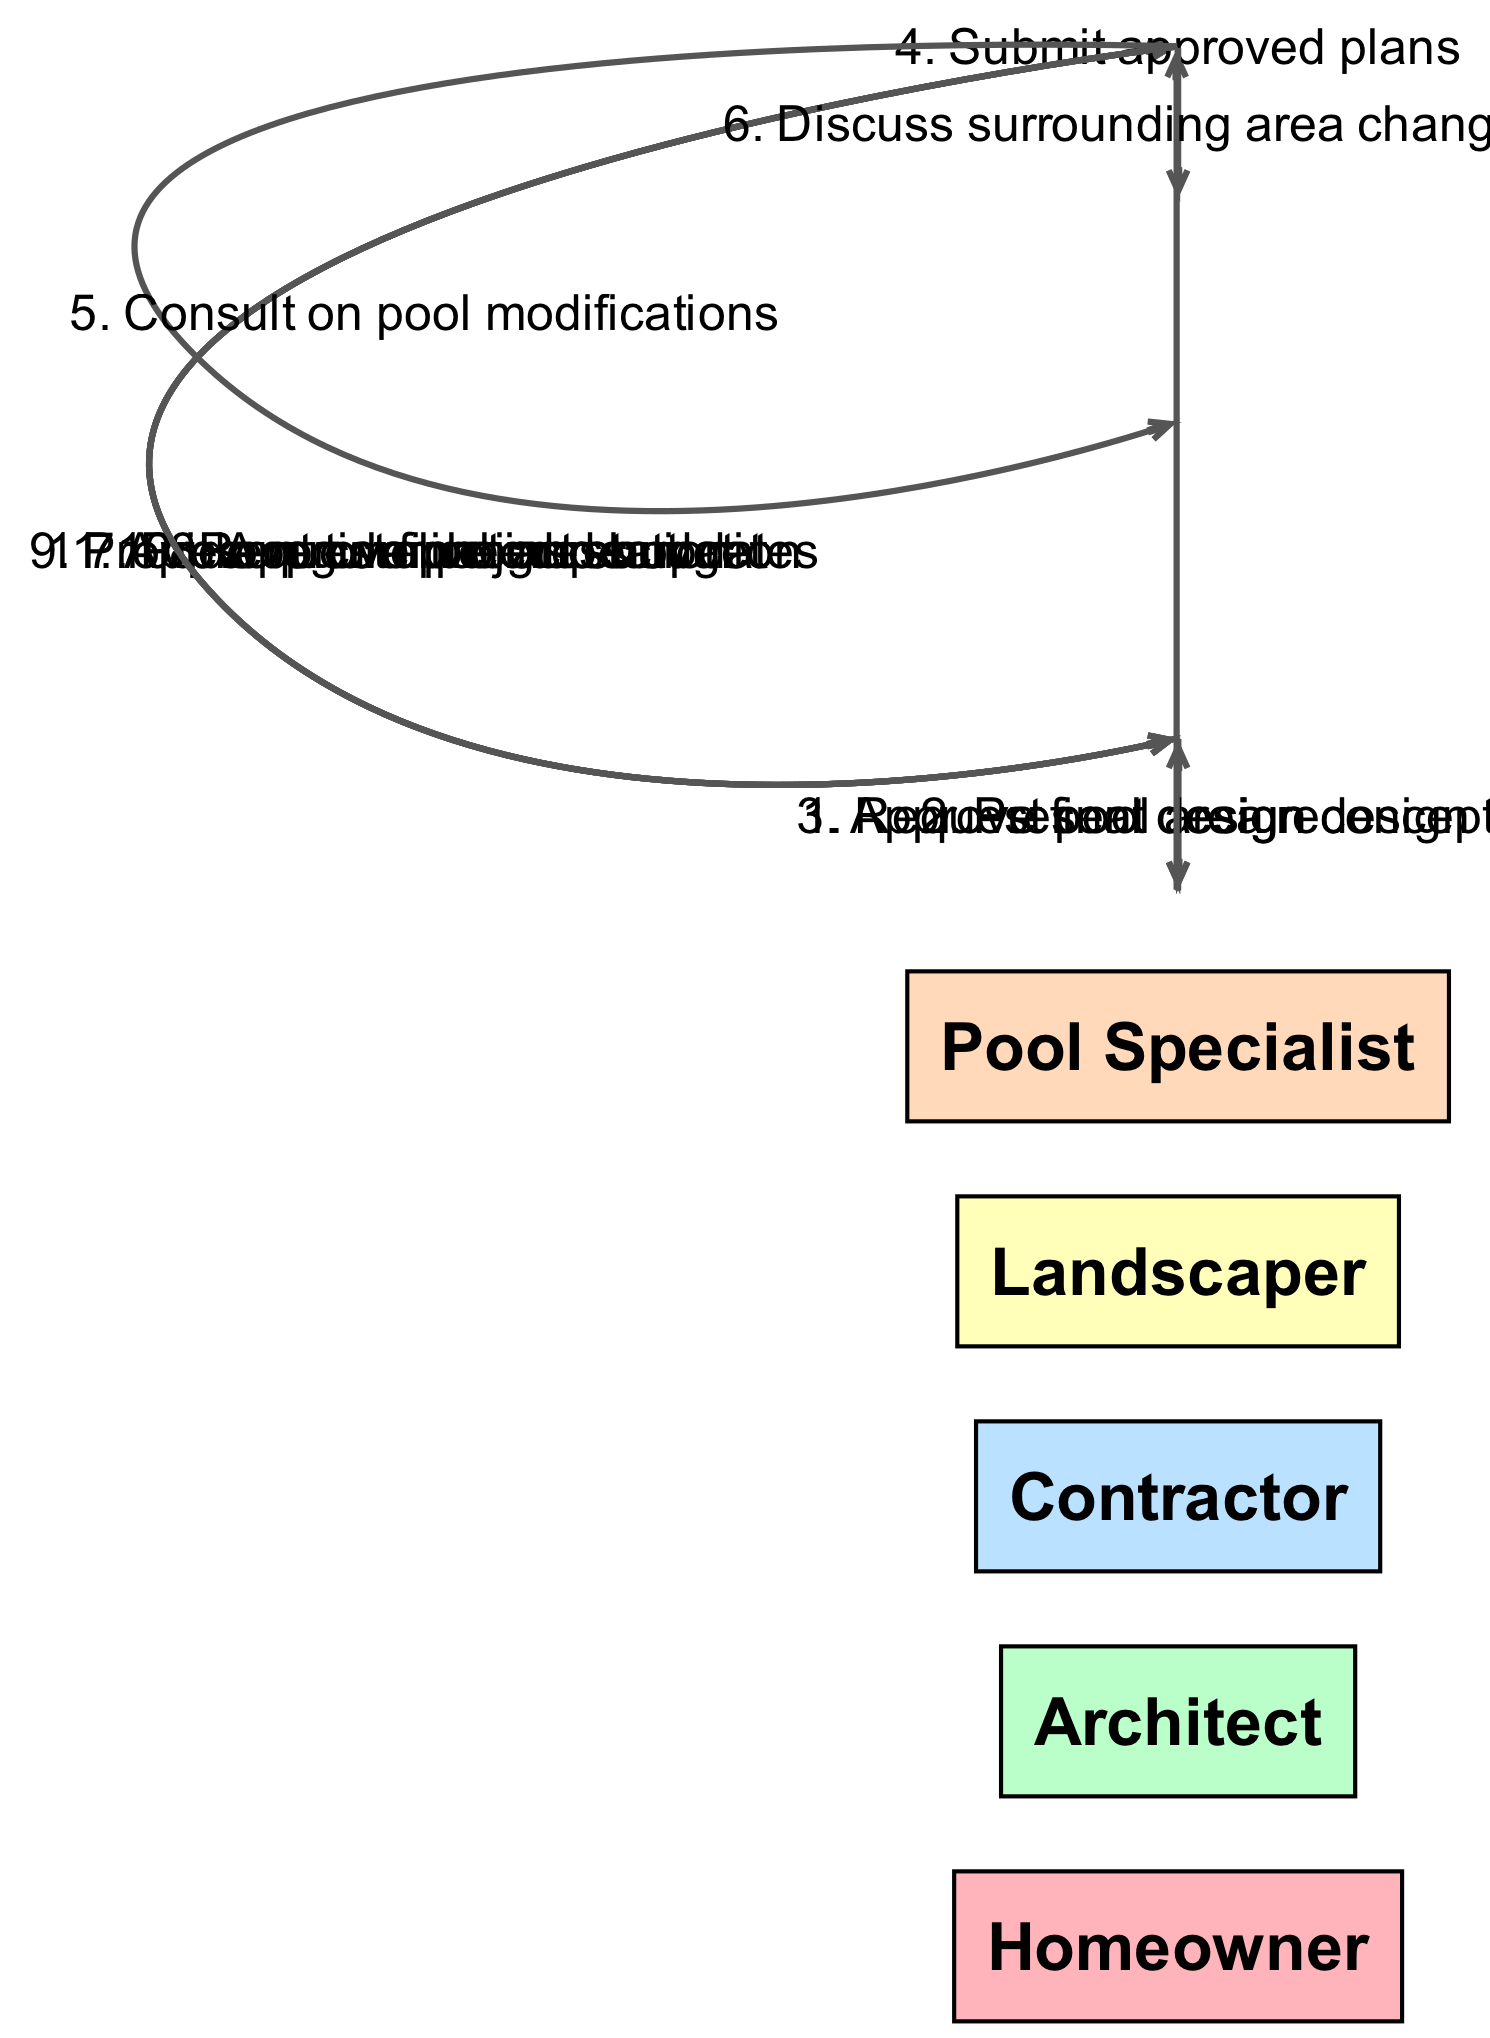What is the first action taken in the sequence? The first action is initiated by the Homeowner who requests a pool area redesign from the Architect.
Answer: Request pool area redesign Who presents design concepts to the Homeowner? According to the diagram, the Architect is responsible for presenting design concepts to the Homeowner after receiving the request.
Answer: Architect How many actors are involved in the renovation process? By reviewing the diagram, we can count a total of five actors involved in the renovation process: Homeowner, Architect, Contractor, Landscaper, and Pool Specialist.
Answer: Five Which actor does the Contractor consult for pool modifications? The diagram shows that the Contractor consults the Pool Specialist for advice on pool modifications.
Answer: Pool Specialist What is the final action before the renovation is approved by the Homeowner? The final action is that the Contractor requests a final inspection before the Homeowner approves the completed renovation.
Answer: Request final inspection What message is conveyed from the Architect to the Contractor? The Architect submits the approved plans to the Contractor as part of the collaboration to move forward with the renovation.
Answer: Submit approved plans How does the Homeowner respond to the project timeline and budget presented by the Contractor? The Homeowner approves the project start after reviewing the timeline and budget provided by the Contractor.
Answer: Approve project start What type of updates does the Contractor provide to the Homeowner during the renovation? The Contractor provides regular progress updates to keep the Homeowner informed about the renovation status.
Answer: Regular progress updates What is the total number of messages exchanged in the sequence? By counting the messages in the diagram, we find that there are eleven messages exchanged throughout the renovation sequence.
Answer: Eleven 